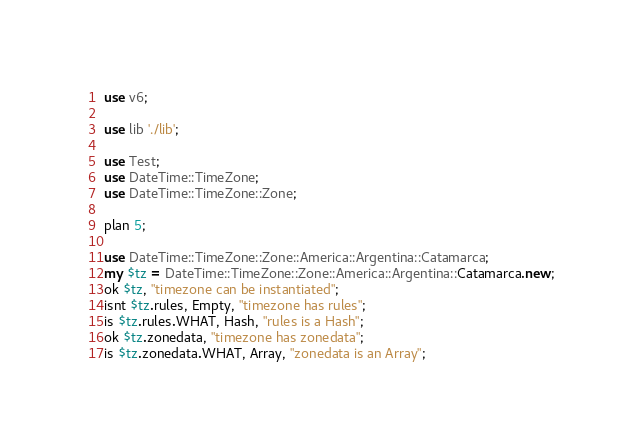Convert code to text. <code><loc_0><loc_0><loc_500><loc_500><_Perl_>use v6;

use lib './lib';

use Test;
use DateTime::TimeZone;
use DateTime::TimeZone::Zone;

plan 5;

use DateTime::TimeZone::Zone::America::Argentina::Catamarca;
my $tz = DateTime::TimeZone::Zone::America::Argentina::Catamarca.new;
ok $tz, "timezone can be instantiated";
isnt $tz.rules, Empty, "timezone has rules";
is $tz.rules.WHAT, Hash, "rules is a Hash";
ok $tz.zonedata, "timezone has zonedata";
is $tz.zonedata.WHAT, Array, "zonedata is an Array";
</code> 